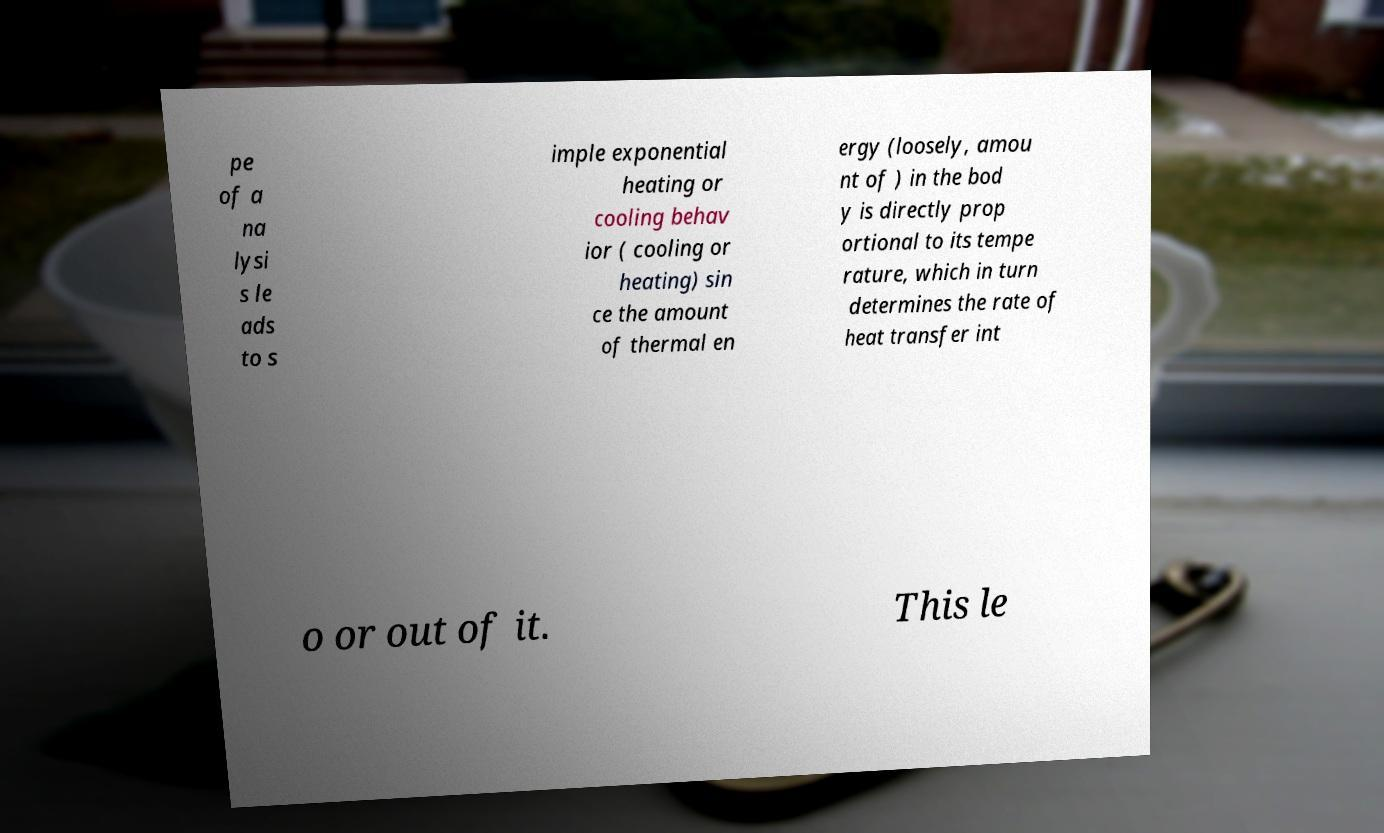For documentation purposes, I need the text within this image transcribed. Could you provide that? pe of a na lysi s le ads to s imple exponential heating or cooling behav ior ( cooling or heating) sin ce the amount of thermal en ergy (loosely, amou nt of ) in the bod y is directly prop ortional to its tempe rature, which in turn determines the rate of heat transfer int o or out of it. This le 